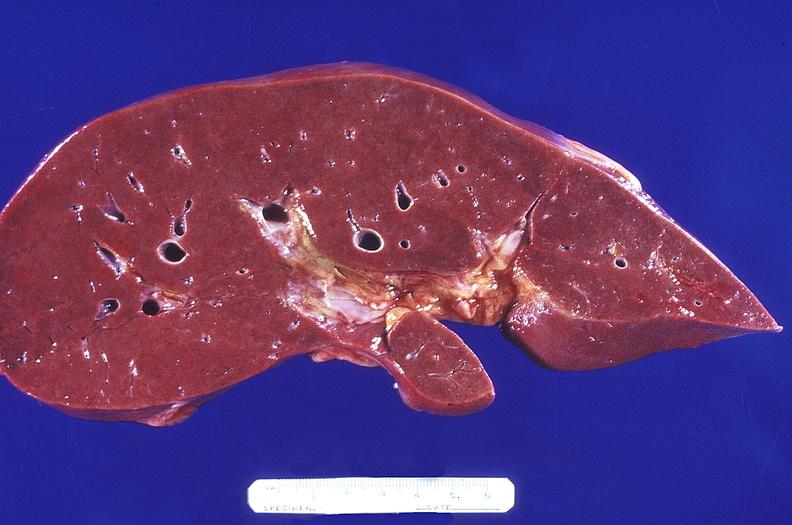s good example of muscle atrophy present?
Answer the question using a single word or phrase. No 